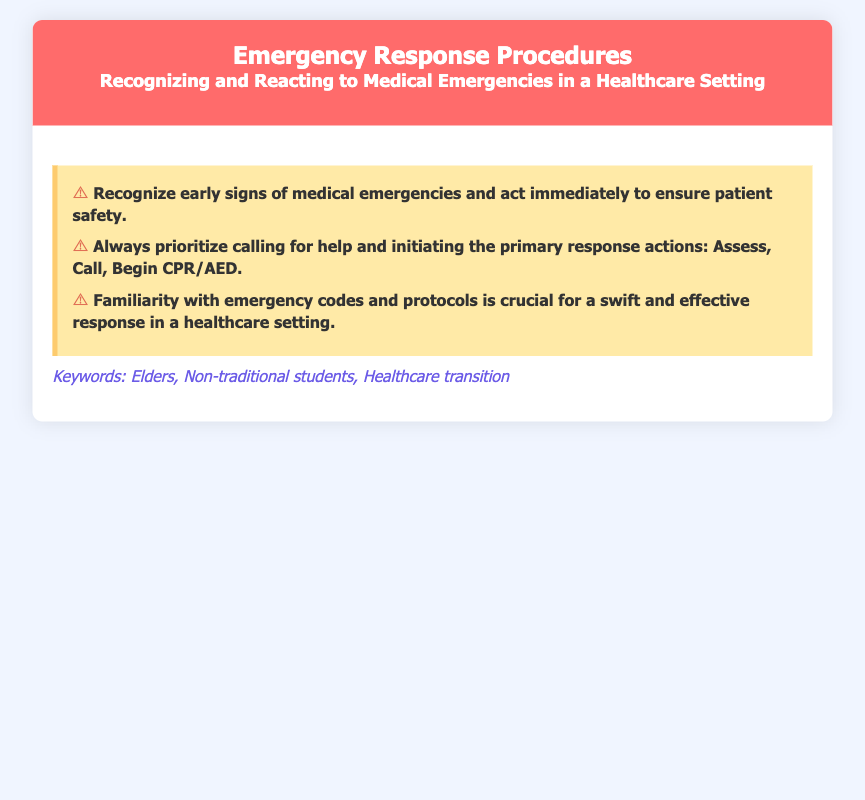What is the title of the document? The title is stated in the header section of the document.
Answer: Emergency Response Procedures What are the first three words of the subtitle? The subtitle is part of the header and provides more context.
Answer: Recognizing and Reacting What is one of the keywords mentioned in the document? The keywords are listed at the bottom of the content section.
Answer: Elders What action should always be prioritized in an emergency? This information is outlined in the warning signs section.
Answer: Calling for help What is the color scheme for the warning signs background? The background color is described in the style section.
Answer: Yellow What does CPR stand for? This term appears in the primary response actions mentioned in the document.
Answer: Cardiopulmonary Resuscitation How many warning signs are listed in the document? The number of warning signs is counted in the warning signs section.
Answer: Three What is crucial for a swift response in a healthcare setting? This information is described in a specific warning sign.
Answer: Familiarity with emergency codes and protocols What does the warning sign say about recognizing early signs? This is a direct quote from the content in the warning signs section.
Answer: Act immediately to ensure patient safety 